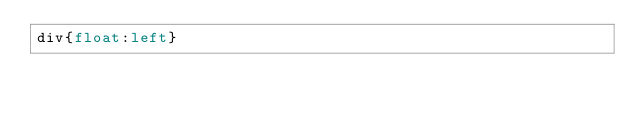Convert code to text. <code><loc_0><loc_0><loc_500><loc_500><_CSS_>div{float:left}</code> 